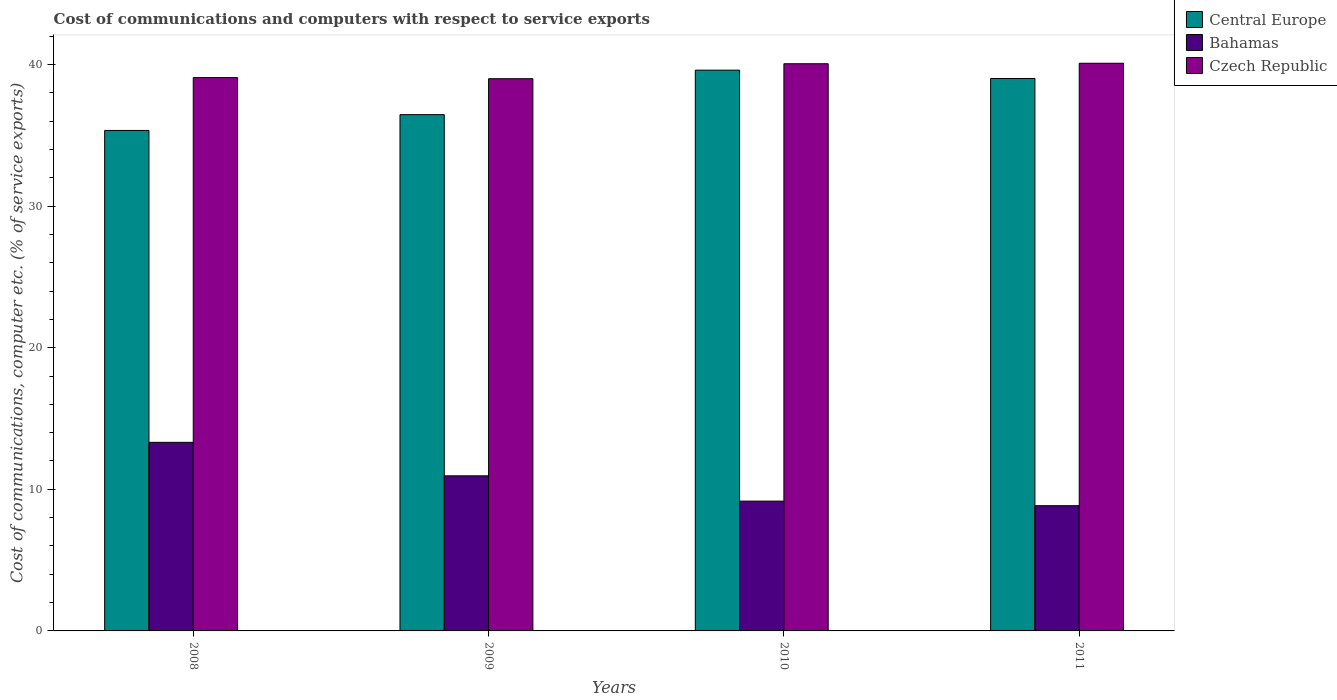How many different coloured bars are there?
Your answer should be very brief. 3. How many groups of bars are there?
Your response must be concise. 4. How many bars are there on the 2nd tick from the left?
Offer a very short reply. 3. How many bars are there on the 3rd tick from the right?
Your answer should be compact. 3. What is the label of the 2nd group of bars from the left?
Make the answer very short. 2009. What is the cost of communications and computers in Czech Republic in 2009?
Give a very brief answer. 38.99. Across all years, what is the maximum cost of communications and computers in Czech Republic?
Your response must be concise. 40.09. Across all years, what is the minimum cost of communications and computers in Bahamas?
Provide a short and direct response. 8.84. In which year was the cost of communications and computers in Czech Republic maximum?
Give a very brief answer. 2011. What is the total cost of communications and computers in Bahamas in the graph?
Ensure brevity in your answer.  42.28. What is the difference between the cost of communications and computers in Central Europe in 2010 and that in 2011?
Make the answer very short. 0.59. What is the difference between the cost of communications and computers in Central Europe in 2008 and the cost of communications and computers in Czech Republic in 2009?
Provide a succinct answer. -3.65. What is the average cost of communications and computers in Central Europe per year?
Provide a short and direct response. 37.6. In the year 2009, what is the difference between the cost of communications and computers in Czech Republic and cost of communications and computers in Central Europe?
Keep it short and to the point. 2.54. What is the ratio of the cost of communications and computers in Czech Republic in 2008 to that in 2009?
Your answer should be compact. 1. Is the cost of communications and computers in Central Europe in 2009 less than that in 2010?
Provide a short and direct response. Yes. What is the difference between the highest and the second highest cost of communications and computers in Bahamas?
Your answer should be compact. 2.37. What is the difference between the highest and the lowest cost of communications and computers in Bahamas?
Offer a very short reply. 4.47. In how many years, is the cost of communications and computers in Czech Republic greater than the average cost of communications and computers in Czech Republic taken over all years?
Provide a succinct answer. 2. Is the sum of the cost of communications and computers in Central Europe in 2008 and 2009 greater than the maximum cost of communications and computers in Bahamas across all years?
Offer a terse response. Yes. What does the 3rd bar from the left in 2008 represents?
Offer a terse response. Czech Republic. What does the 3rd bar from the right in 2009 represents?
Offer a terse response. Central Europe. How many bars are there?
Ensure brevity in your answer.  12. Are all the bars in the graph horizontal?
Provide a succinct answer. No. How many years are there in the graph?
Offer a terse response. 4. Does the graph contain grids?
Keep it short and to the point. No. How many legend labels are there?
Provide a succinct answer. 3. What is the title of the graph?
Provide a short and direct response. Cost of communications and computers with respect to service exports. What is the label or title of the Y-axis?
Your response must be concise. Cost of communications, computer etc. (% of service exports). What is the Cost of communications, computer etc. (% of service exports) of Central Europe in 2008?
Ensure brevity in your answer.  35.34. What is the Cost of communications, computer etc. (% of service exports) in Bahamas in 2008?
Offer a terse response. 13.32. What is the Cost of communications, computer etc. (% of service exports) in Czech Republic in 2008?
Provide a short and direct response. 39.07. What is the Cost of communications, computer etc. (% of service exports) in Central Europe in 2009?
Your answer should be compact. 36.46. What is the Cost of communications, computer etc. (% of service exports) of Bahamas in 2009?
Your response must be concise. 10.95. What is the Cost of communications, computer etc. (% of service exports) of Czech Republic in 2009?
Offer a very short reply. 38.99. What is the Cost of communications, computer etc. (% of service exports) of Central Europe in 2010?
Ensure brevity in your answer.  39.6. What is the Cost of communications, computer etc. (% of service exports) in Bahamas in 2010?
Your response must be concise. 9.17. What is the Cost of communications, computer etc. (% of service exports) of Czech Republic in 2010?
Your response must be concise. 40.05. What is the Cost of communications, computer etc. (% of service exports) of Central Europe in 2011?
Your response must be concise. 39.01. What is the Cost of communications, computer etc. (% of service exports) in Bahamas in 2011?
Provide a short and direct response. 8.84. What is the Cost of communications, computer etc. (% of service exports) in Czech Republic in 2011?
Provide a short and direct response. 40.09. Across all years, what is the maximum Cost of communications, computer etc. (% of service exports) in Central Europe?
Offer a terse response. 39.6. Across all years, what is the maximum Cost of communications, computer etc. (% of service exports) of Bahamas?
Make the answer very short. 13.32. Across all years, what is the maximum Cost of communications, computer etc. (% of service exports) in Czech Republic?
Provide a short and direct response. 40.09. Across all years, what is the minimum Cost of communications, computer etc. (% of service exports) in Central Europe?
Your answer should be very brief. 35.34. Across all years, what is the minimum Cost of communications, computer etc. (% of service exports) in Bahamas?
Make the answer very short. 8.84. Across all years, what is the minimum Cost of communications, computer etc. (% of service exports) in Czech Republic?
Make the answer very short. 38.99. What is the total Cost of communications, computer etc. (% of service exports) of Central Europe in the graph?
Keep it short and to the point. 150.41. What is the total Cost of communications, computer etc. (% of service exports) in Bahamas in the graph?
Provide a succinct answer. 42.28. What is the total Cost of communications, computer etc. (% of service exports) in Czech Republic in the graph?
Give a very brief answer. 158.2. What is the difference between the Cost of communications, computer etc. (% of service exports) in Central Europe in 2008 and that in 2009?
Your response must be concise. -1.12. What is the difference between the Cost of communications, computer etc. (% of service exports) of Bahamas in 2008 and that in 2009?
Provide a short and direct response. 2.37. What is the difference between the Cost of communications, computer etc. (% of service exports) in Czech Republic in 2008 and that in 2009?
Offer a very short reply. 0.08. What is the difference between the Cost of communications, computer etc. (% of service exports) in Central Europe in 2008 and that in 2010?
Your answer should be compact. -4.26. What is the difference between the Cost of communications, computer etc. (% of service exports) of Bahamas in 2008 and that in 2010?
Your answer should be very brief. 4.15. What is the difference between the Cost of communications, computer etc. (% of service exports) of Czech Republic in 2008 and that in 2010?
Ensure brevity in your answer.  -0.98. What is the difference between the Cost of communications, computer etc. (% of service exports) of Central Europe in 2008 and that in 2011?
Offer a very short reply. -3.67. What is the difference between the Cost of communications, computer etc. (% of service exports) in Bahamas in 2008 and that in 2011?
Provide a short and direct response. 4.47. What is the difference between the Cost of communications, computer etc. (% of service exports) of Czech Republic in 2008 and that in 2011?
Make the answer very short. -1.01. What is the difference between the Cost of communications, computer etc. (% of service exports) in Central Europe in 2009 and that in 2010?
Give a very brief answer. -3.14. What is the difference between the Cost of communications, computer etc. (% of service exports) of Bahamas in 2009 and that in 2010?
Make the answer very short. 1.79. What is the difference between the Cost of communications, computer etc. (% of service exports) in Czech Republic in 2009 and that in 2010?
Keep it short and to the point. -1.06. What is the difference between the Cost of communications, computer etc. (% of service exports) of Central Europe in 2009 and that in 2011?
Ensure brevity in your answer.  -2.55. What is the difference between the Cost of communications, computer etc. (% of service exports) in Bahamas in 2009 and that in 2011?
Your answer should be compact. 2.11. What is the difference between the Cost of communications, computer etc. (% of service exports) in Czech Republic in 2009 and that in 2011?
Make the answer very short. -1.09. What is the difference between the Cost of communications, computer etc. (% of service exports) in Central Europe in 2010 and that in 2011?
Provide a short and direct response. 0.59. What is the difference between the Cost of communications, computer etc. (% of service exports) in Bahamas in 2010 and that in 2011?
Provide a succinct answer. 0.32. What is the difference between the Cost of communications, computer etc. (% of service exports) of Czech Republic in 2010 and that in 2011?
Offer a terse response. -0.03. What is the difference between the Cost of communications, computer etc. (% of service exports) in Central Europe in 2008 and the Cost of communications, computer etc. (% of service exports) in Bahamas in 2009?
Your response must be concise. 24.39. What is the difference between the Cost of communications, computer etc. (% of service exports) of Central Europe in 2008 and the Cost of communications, computer etc. (% of service exports) of Czech Republic in 2009?
Your answer should be very brief. -3.65. What is the difference between the Cost of communications, computer etc. (% of service exports) in Bahamas in 2008 and the Cost of communications, computer etc. (% of service exports) in Czech Republic in 2009?
Your answer should be very brief. -25.68. What is the difference between the Cost of communications, computer etc. (% of service exports) in Central Europe in 2008 and the Cost of communications, computer etc. (% of service exports) in Bahamas in 2010?
Give a very brief answer. 26.18. What is the difference between the Cost of communications, computer etc. (% of service exports) in Central Europe in 2008 and the Cost of communications, computer etc. (% of service exports) in Czech Republic in 2010?
Offer a very short reply. -4.71. What is the difference between the Cost of communications, computer etc. (% of service exports) of Bahamas in 2008 and the Cost of communications, computer etc. (% of service exports) of Czech Republic in 2010?
Offer a very short reply. -26.73. What is the difference between the Cost of communications, computer etc. (% of service exports) in Central Europe in 2008 and the Cost of communications, computer etc. (% of service exports) in Bahamas in 2011?
Offer a very short reply. 26.5. What is the difference between the Cost of communications, computer etc. (% of service exports) of Central Europe in 2008 and the Cost of communications, computer etc. (% of service exports) of Czech Republic in 2011?
Make the answer very short. -4.74. What is the difference between the Cost of communications, computer etc. (% of service exports) in Bahamas in 2008 and the Cost of communications, computer etc. (% of service exports) in Czech Republic in 2011?
Your answer should be very brief. -26.77. What is the difference between the Cost of communications, computer etc. (% of service exports) of Central Europe in 2009 and the Cost of communications, computer etc. (% of service exports) of Bahamas in 2010?
Give a very brief answer. 27.29. What is the difference between the Cost of communications, computer etc. (% of service exports) in Central Europe in 2009 and the Cost of communications, computer etc. (% of service exports) in Czech Republic in 2010?
Your response must be concise. -3.59. What is the difference between the Cost of communications, computer etc. (% of service exports) of Bahamas in 2009 and the Cost of communications, computer etc. (% of service exports) of Czech Republic in 2010?
Keep it short and to the point. -29.1. What is the difference between the Cost of communications, computer etc. (% of service exports) in Central Europe in 2009 and the Cost of communications, computer etc. (% of service exports) in Bahamas in 2011?
Ensure brevity in your answer.  27.61. What is the difference between the Cost of communications, computer etc. (% of service exports) of Central Europe in 2009 and the Cost of communications, computer etc. (% of service exports) of Czech Republic in 2011?
Give a very brief answer. -3.63. What is the difference between the Cost of communications, computer etc. (% of service exports) in Bahamas in 2009 and the Cost of communications, computer etc. (% of service exports) in Czech Republic in 2011?
Make the answer very short. -29.13. What is the difference between the Cost of communications, computer etc. (% of service exports) in Central Europe in 2010 and the Cost of communications, computer etc. (% of service exports) in Bahamas in 2011?
Give a very brief answer. 30.76. What is the difference between the Cost of communications, computer etc. (% of service exports) of Central Europe in 2010 and the Cost of communications, computer etc. (% of service exports) of Czech Republic in 2011?
Keep it short and to the point. -0.49. What is the difference between the Cost of communications, computer etc. (% of service exports) in Bahamas in 2010 and the Cost of communications, computer etc. (% of service exports) in Czech Republic in 2011?
Provide a succinct answer. -30.92. What is the average Cost of communications, computer etc. (% of service exports) in Central Europe per year?
Give a very brief answer. 37.6. What is the average Cost of communications, computer etc. (% of service exports) in Bahamas per year?
Your response must be concise. 10.57. What is the average Cost of communications, computer etc. (% of service exports) in Czech Republic per year?
Ensure brevity in your answer.  39.55. In the year 2008, what is the difference between the Cost of communications, computer etc. (% of service exports) in Central Europe and Cost of communications, computer etc. (% of service exports) in Bahamas?
Ensure brevity in your answer.  22.02. In the year 2008, what is the difference between the Cost of communications, computer etc. (% of service exports) of Central Europe and Cost of communications, computer etc. (% of service exports) of Czech Republic?
Give a very brief answer. -3.73. In the year 2008, what is the difference between the Cost of communications, computer etc. (% of service exports) in Bahamas and Cost of communications, computer etc. (% of service exports) in Czech Republic?
Provide a short and direct response. -25.76. In the year 2009, what is the difference between the Cost of communications, computer etc. (% of service exports) in Central Europe and Cost of communications, computer etc. (% of service exports) in Bahamas?
Your response must be concise. 25.51. In the year 2009, what is the difference between the Cost of communications, computer etc. (% of service exports) in Central Europe and Cost of communications, computer etc. (% of service exports) in Czech Republic?
Keep it short and to the point. -2.54. In the year 2009, what is the difference between the Cost of communications, computer etc. (% of service exports) of Bahamas and Cost of communications, computer etc. (% of service exports) of Czech Republic?
Your answer should be very brief. -28.04. In the year 2010, what is the difference between the Cost of communications, computer etc. (% of service exports) in Central Europe and Cost of communications, computer etc. (% of service exports) in Bahamas?
Give a very brief answer. 30.43. In the year 2010, what is the difference between the Cost of communications, computer etc. (% of service exports) in Central Europe and Cost of communications, computer etc. (% of service exports) in Czech Republic?
Give a very brief answer. -0.45. In the year 2010, what is the difference between the Cost of communications, computer etc. (% of service exports) of Bahamas and Cost of communications, computer etc. (% of service exports) of Czech Republic?
Provide a short and direct response. -30.89. In the year 2011, what is the difference between the Cost of communications, computer etc. (% of service exports) in Central Europe and Cost of communications, computer etc. (% of service exports) in Bahamas?
Give a very brief answer. 30.17. In the year 2011, what is the difference between the Cost of communications, computer etc. (% of service exports) in Central Europe and Cost of communications, computer etc. (% of service exports) in Czech Republic?
Give a very brief answer. -1.07. In the year 2011, what is the difference between the Cost of communications, computer etc. (% of service exports) of Bahamas and Cost of communications, computer etc. (% of service exports) of Czech Republic?
Make the answer very short. -31.24. What is the ratio of the Cost of communications, computer etc. (% of service exports) in Central Europe in 2008 to that in 2009?
Offer a very short reply. 0.97. What is the ratio of the Cost of communications, computer etc. (% of service exports) of Bahamas in 2008 to that in 2009?
Your response must be concise. 1.22. What is the ratio of the Cost of communications, computer etc. (% of service exports) in Central Europe in 2008 to that in 2010?
Make the answer very short. 0.89. What is the ratio of the Cost of communications, computer etc. (% of service exports) of Bahamas in 2008 to that in 2010?
Your answer should be very brief. 1.45. What is the ratio of the Cost of communications, computer etc. (% of service exports) in Czech Republic in 2008 to that in 2010?
Give a very brief answer. 0.98. What is the ratio of the Cost of communications, computer etc. (% of service exports) of Central Europe in 2008 to that in 2011?
Give a very brief answer. 0.91. What is the ratio of the Cost of communications, computer etc. (% of service exports) of Bahamas in 2008 to that in 2011?
Give a very brief answer. 1.51. What is the ratio of the Cost of communications, computer etc. (% of service exports) of Czech Republic in 2008 to that in 2011?
Give a very brief answer. 0.97. What is the ratio of the Cost of communications, computer etc. (% of service exports) of Central Europe in 2009 to that in 2010?
Your answer should be very brief. 0.92. What is the ratio of the Cost of communications, computer etc. (% of service exports) of Bahamas in 2009 to that in 2010?
Keep it short and to the point. 1.19. What is the ratio of the Cost of communications, computer etc. (% of service exports) of Czech Republic in 2009 to that in 2010?
Offer a very short reply. 0.97. What is the ratio of the Cost of communications, computer etc. (% of service exports) in Central Europe in 2009 to that in 2011?
Keep it short and to the point. 0.93. What is the ratio of the Cost of communications, computer etc. (% of service exports) in Bahamas in 2009 to that in 2011?
Give a very brief answer. 1.24. What is the ratio of the Cost of communications, computer etc. (% of service exports) in Czech Republic in 2009 to that in 2011?
Keep it short and to the point. 0.97. What is the ratio of the Cost of communications, computer etc. (% of service exports) of Central Europe in 2010 to that in 2011?
Your answer should be very brief. 1.02. What is the ratio of the Cost of communications, computer etc. (% of service exports) of Bahamas in 2010 to that in 2011?
Your answer should be compact. 1.04. What is the difference between the highest and the second highest Cost of communications, computer etc. (% of service exports) in Central Europe?
Your answer should be very brief. 0.59. What is the difference between the highest and the second highest Cost of communications, computer etc. (% of service exports) in Bahamas?
Your answer should be very brief. 2.37. What is the difference between the highest and the second highest Cost of communications, computer etc. (% of service exports) of Czech Republic?
Offer a terse response. 0.03. What is the difference between the highest and the lowest Cost of communications, computer etc. (% of service exports) in Central Europe?
Provide a short and direct response. 4.26. What is the difference between the highest and the lowest Cost of communications, computer etc. (% of service exports) of Bahamas?
Give a very brief answer. 4.47. What is the difference between the highest and the lowest Cost of communications, computer etc. (% of service exports) of Czech Republic?
Ensure brevity in your answer.  1.09. 